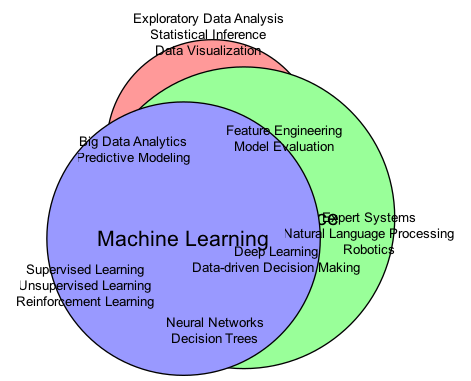What are the unique elements of Data Science? The diagram represents the unique elements of Data Science in the corresponding circle, which includes "Exploratory Data Analysis," "Statistical Inference," and "Data Visualization."
Answer: Exploratory Data Analysis, Statistical Inference, Data Visualization How many unique elements does Artificial Intelligence have? By examining the circle for Artificial Intelligence, we can see that it contains three unique elements: "Expert Systems," "Natural Language Processing," and "Robotics." Therefore, the count is three.
Answer: 3 What elements are shared between Data Science and Machine Learning? The diagram shows the overlap between Data Science and Machine Learning, which includes "Feature Engineering" and "Model Evaluation." These are the elements that both fields share, indicating their intersection.
Answer: Feature Engineering, Model Evaluation Which elements are common to all three fields? In the center area where all three circles intersect, the elements listed are "Deep Learning" and "Data-driven Decision Making." This indicates these concepts are fundamental to the integration of Data Science, Artificial Intelligence, and Machine Learning.
Answer: Deep Learning, Data-driven Decision Making What is the unique element of Machine Learning? The Machine Learning circle specifically lists "Supervised Learning," "Unsupervised Learning," and "Reinforcement Learning" as its unique elements. This indicates the focus of Machine Learning distinct from the others.
Answer: Supervised Learning, Unsupervised Learning, Reinforcement Learning How many elements are there in the overlap between Artificial Intelligence and Machine Learning? Referencing the overlap between Artificial Intelligence and Machine Learning, it features two shared elements, which are "Neural Networks" and "Decision Trees." Therefore, the count of elements in this overlap is two.
Answer: 2 Name an element that belongs only to Data Science. The unique elements of Data Science include "Exploratory Data Analysis," "Statistical Inference," and "Data Visualization," any of which exclusively belong to this domain without overlap with the others.
Answer: Exploratory Data Analysis Which field includes "Robotics"? By checking the unique elements in the Artificial Intelligence circle, we find that "Robotics" is clearly listed as one of its unique components, signifying its specific relevance to that field.
Answer: Artificial Intelligence What represents the concept of "Big Data Analytics"? The diagram indicates that "Big Data Analytics" is an element shared between Data Science and Artificial Intelligence, representing a common application area that utilizes methods from both disciplines.
Answer: Data Science and Artificial Intelligence 